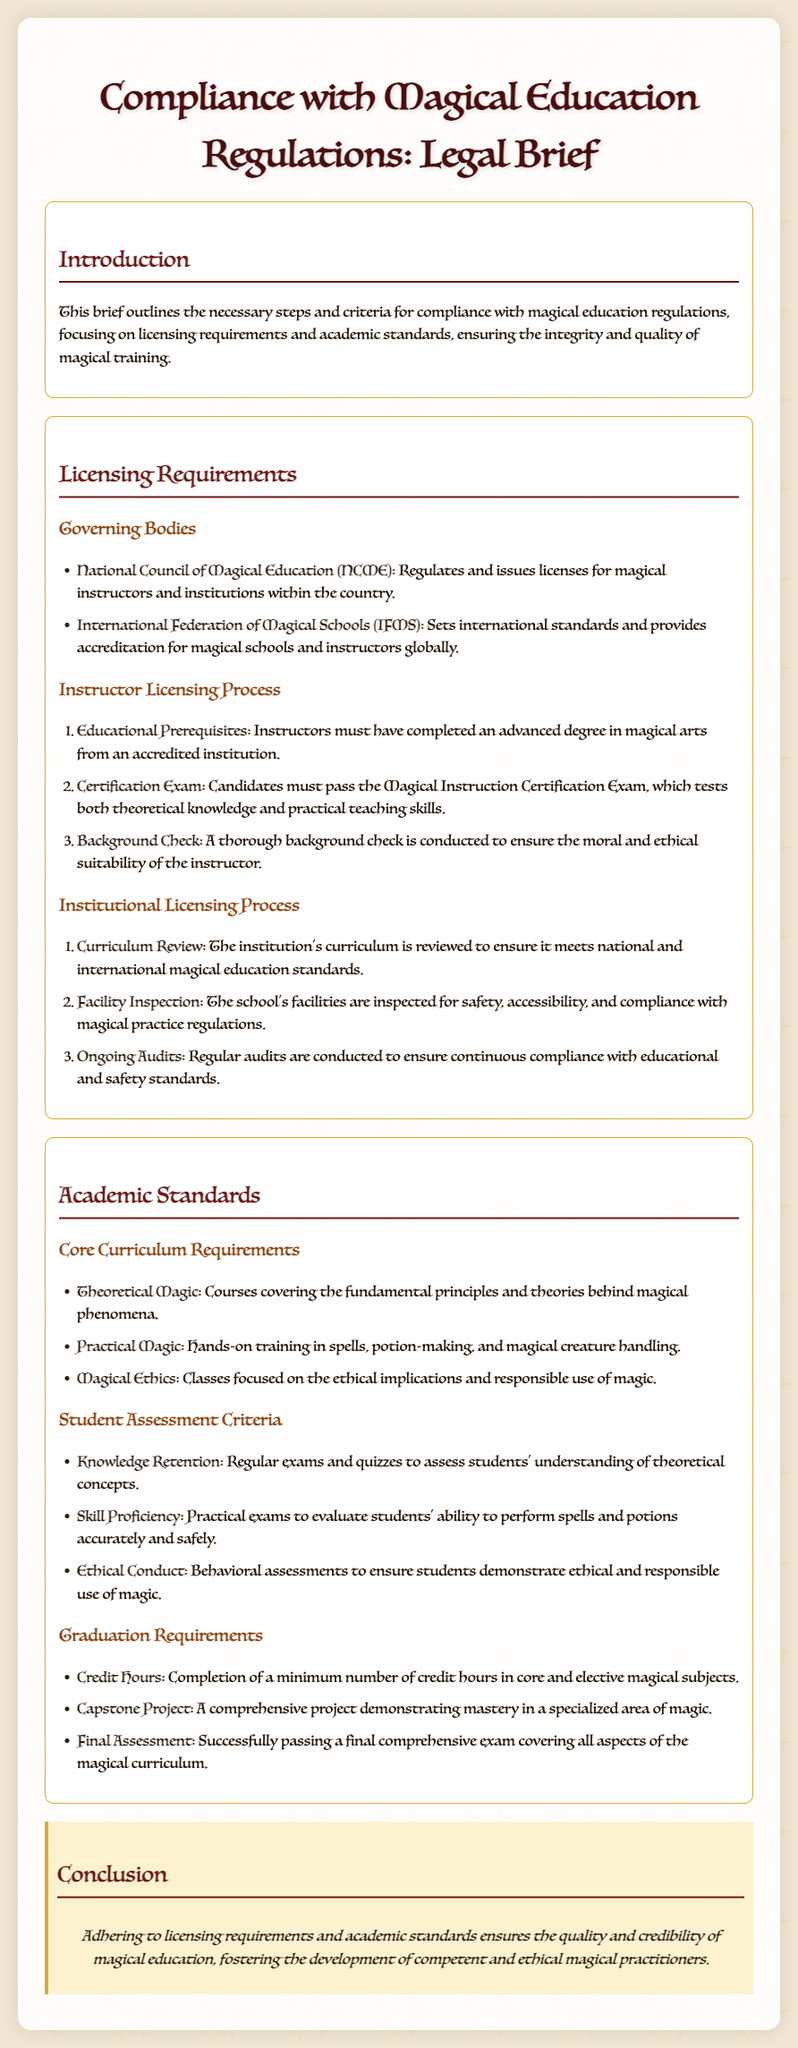What are the governing bodies for magical education? The document lists the National Council of Magical Education and the International Federation of Magical Schools as the governing bodies for magical education.
Answer: National Council of Magical Education, International Federation of Magical Schools What is the first step in the instructor licensing process? According to the document, instructors must have completed an advanced degree in magical arts from an accredited institution as the first step in the licensing process.
Answer: Educational Prerequisites What course is part of the core curriculum requirements? The document specifies several courses, including theoretical magic, which is part of the core curriculum requirements.
Answer: Theoretical Magic What is required for graduation under the graduation requirements? The document outlines multiple requirements for graduation, with the completion of a minimum number of credit hours being one key aspect.
Answer: Credit Hours What do ongoing audits ensure in the institutional licensing process? The document states that ongoing audits are conducted to ensure continuous compliance with educational and safety standards.
Answer: Continuous compliance How many assessments are mentioned for student assessment criteria? The document includes three types of assessments for evaluating students' understanding and skills in magical education.
Answer: Three What does the capstone project demonstrate? As per the document, the capstone project is a requirement that demonstrates mastery in a specialized area of magic.
Answer: Mastery in a specialized area of magic What is the purpose of compliance with magical education regulations? The document explains that compliance with magical education regulations ensures the quality and credibility of magical education.
Answer: Quality and credibility 